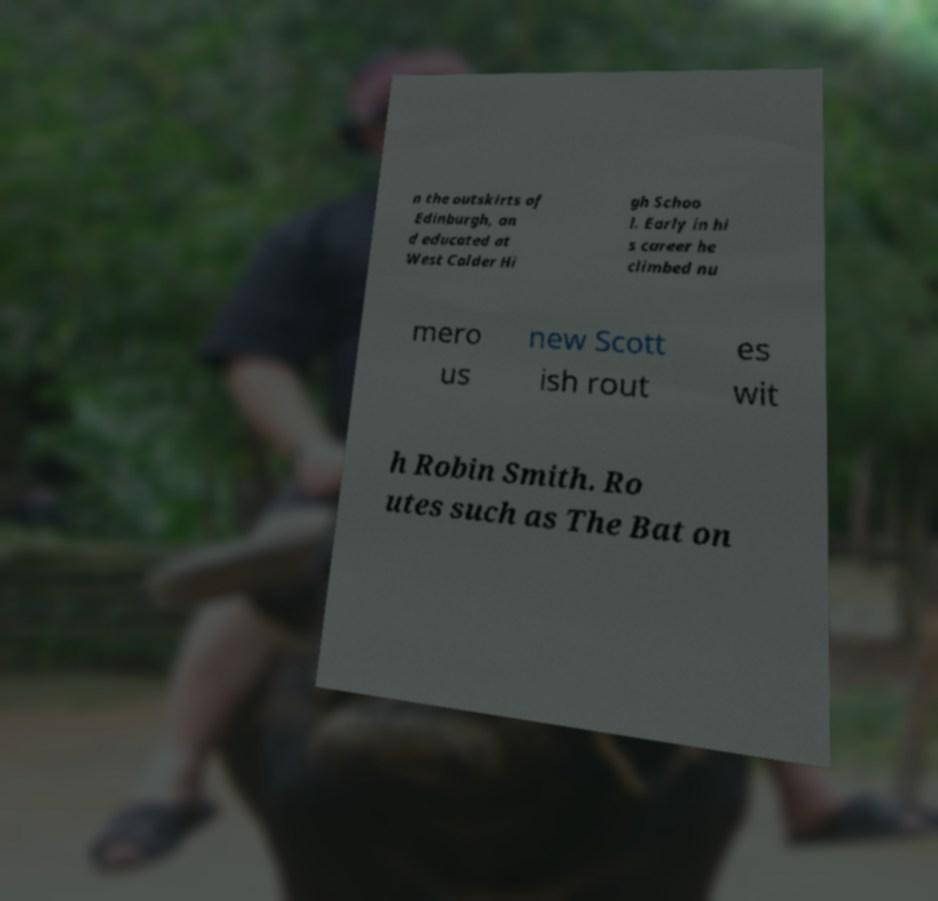For documentation purposes, I need the text within this image transcribed. Could you provide that? n the outskirts of Edinburgh, an d educated at West Calder Hi gh Schoo l. Early in hi s career he climbed nu mero us new Scott ish rout es wit h Robin Smith. Ro utes such as The Bat on 